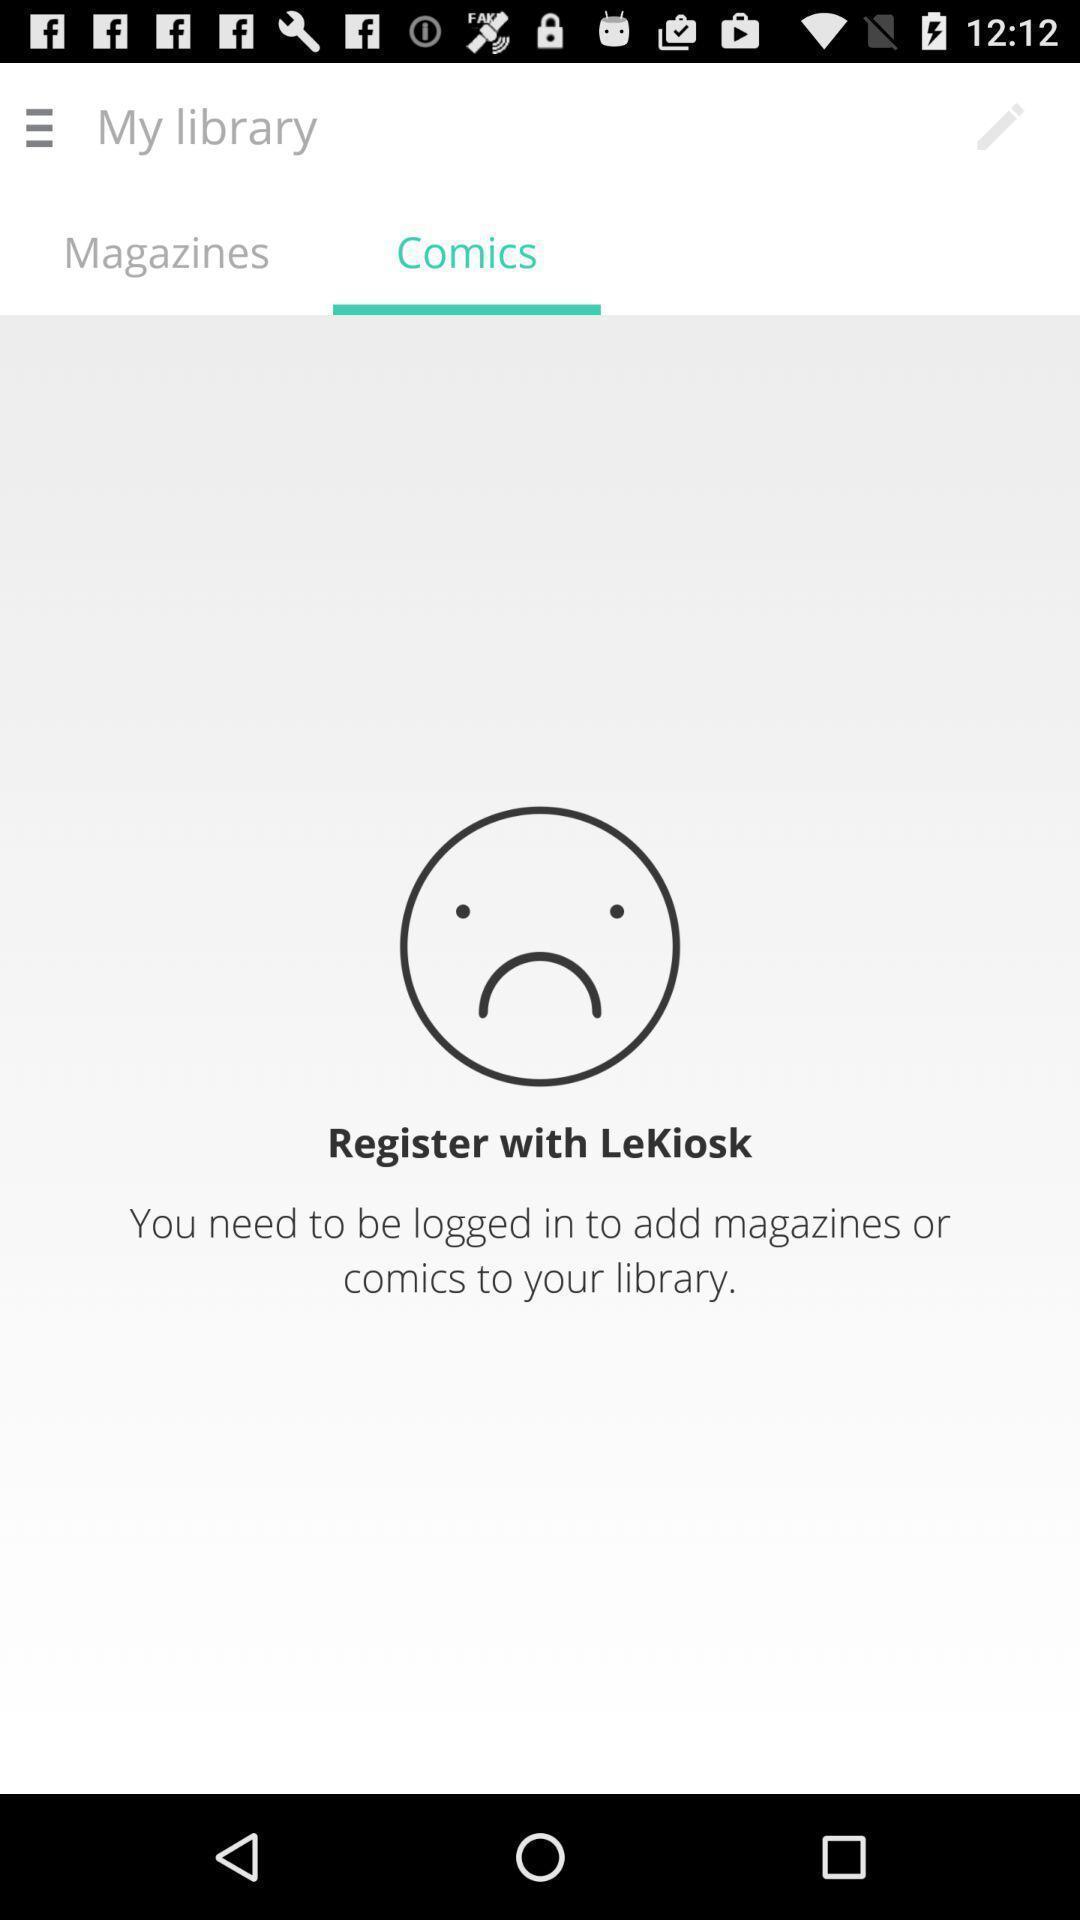What is the overall content of this screenshot? Page showing the comics sections. 